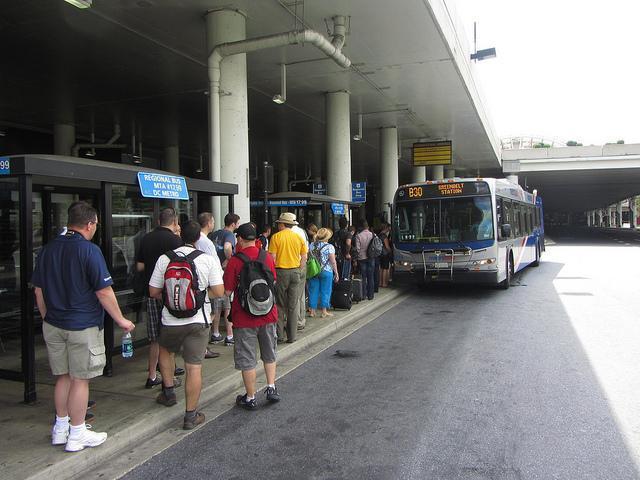How many backpacks are visible?
Give a very brief answer. 2. How many people are there?
Give a very brief answer. 6. How many floor tiles with any part of a cat on them are in the picture?
Give a very brief answer. 0. 